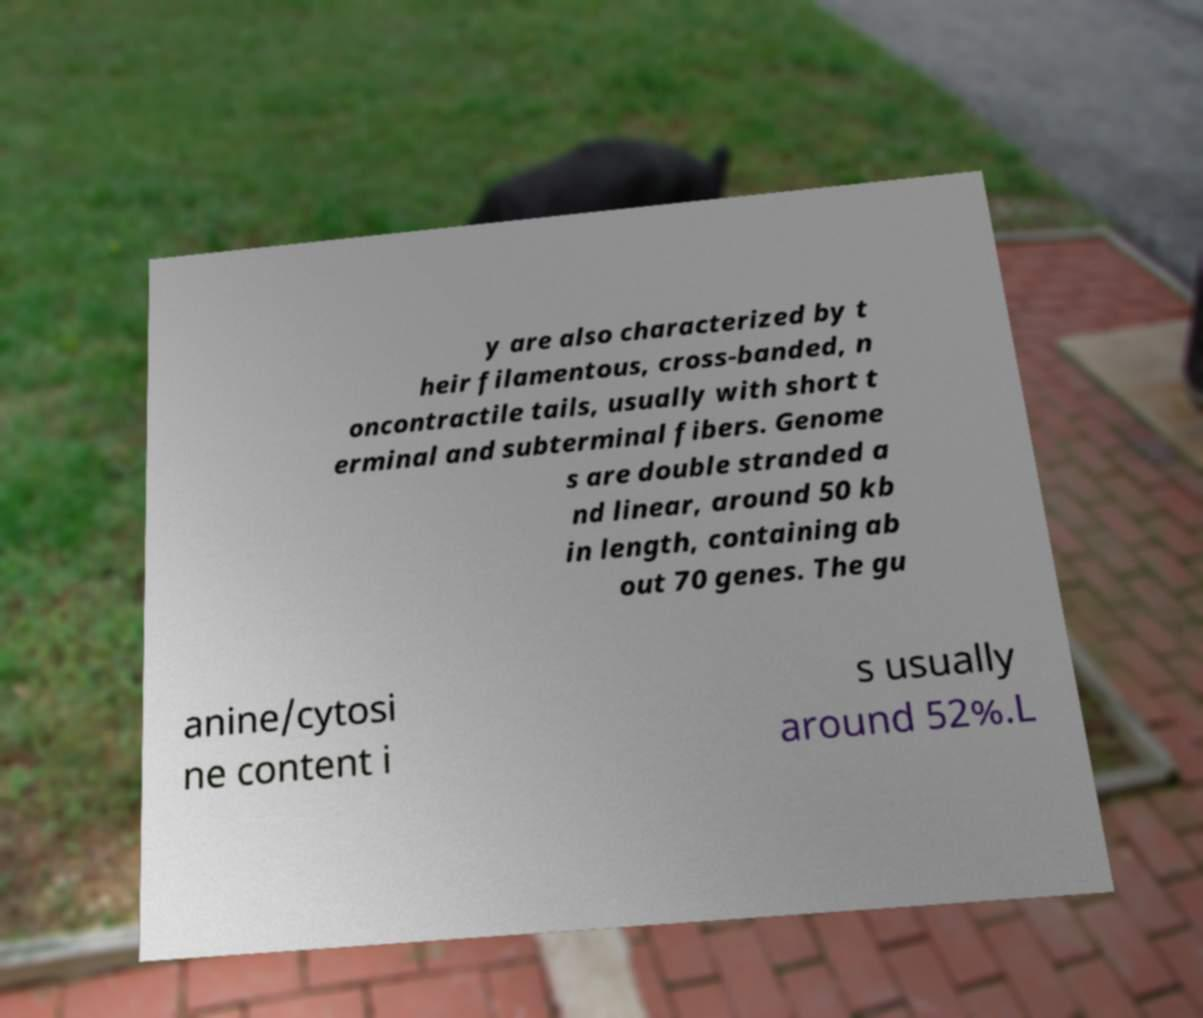Could you assist in decoding the text presented in this image and type it out clearly? y are also characterized by t heir filamentous, cross-banded, n oncontractile tails, usually with short t erminal and subterminal fibers. Genome s are double stranded a nd linear, around 50 kb in length, containing ab out 70 genes. The gu anine/cytosi ne content i s usually around 52%.L 